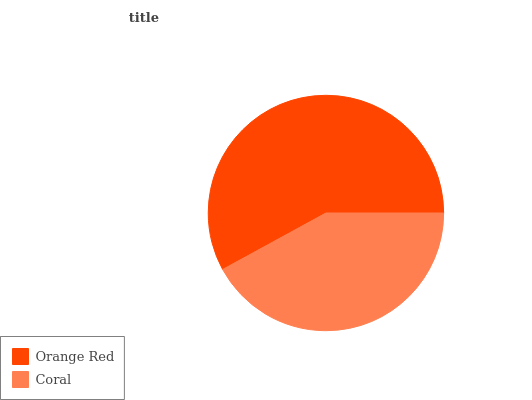Is Coral the minimum?
Answer yes or no. Yes. Is Orange Red the maximum?
Answer yes or no. Yes. Is Coral the maximum?
Answer yes or no. No. Is Orange Red greater than Coral?
Answer yes or no. Yes. Is Coral less than Orange Red?
Answer yes or no. Yes. Is Coral greater than Orange Red?
Answer yes or no. No. Is Orange Red less than Coral?
Answer yes or no. No. Is Orange Red the high median?
Answer yes or no. Yes. Is Coral the low median?
Answer yes or no. Yes. Is Coral the high median?
Answer yes or no. No. Is Orange Red the low median?
Answer yes or no. No. 